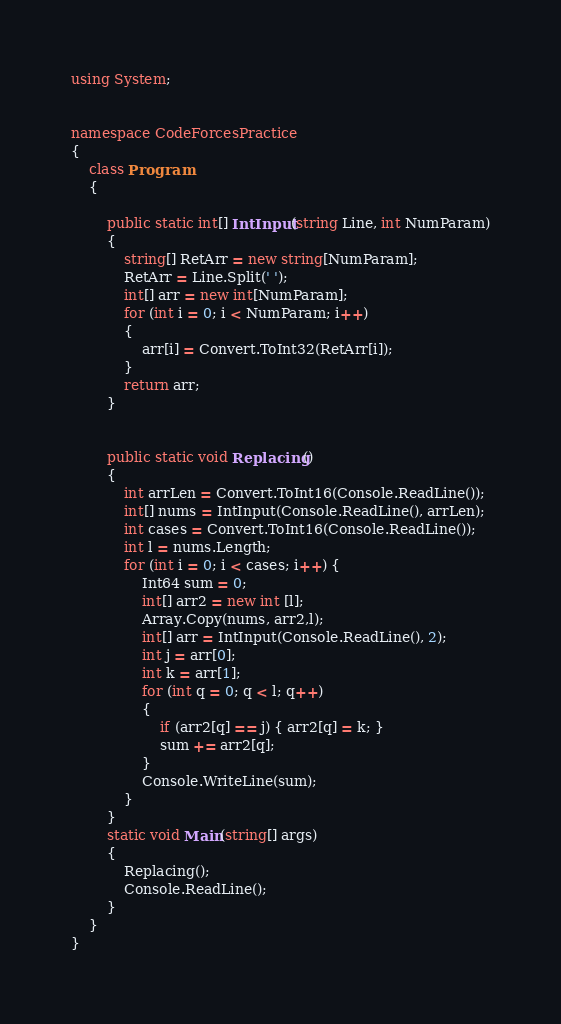Convert code to text. <code><loc_0><loc_0><loc_500><loc_500><_C#_>using System;


namespace CodeForcesPractice
{
    class Program
    {
        
        public static int[] IntInput(string Line, int NumParam)
        {
            string[] RetArr = new string[NumParam];
            RetArr = Line.Split(' ');
            int[] arr = new int[NumParam];
            for (int i = 0; i < NumParam; i++)
            {
                arr[i] = Convert.ToInt32(RetArr[i]);
            }
            return arr;
        }
        

        public static void Replacing()
        {
            int arrLen = Convert.ToInt16(Console.ReadLine());
            int[] nums = IntInput(Console.ReadLine(), arrLen);
            int cases = Convert.ToInt16(Console.ReadLine());
            int l = nums.Length;
            for (int i = 0; i < cases; i++) {
                Int64 sum = 0;
                int[] arr2 = new int [l];
                Array.Copy(nums, arr2,l);
                int[] arr = IntInput(Console.ReadLine(), 2);
                int j = arr[0];
                int k = arr[1];
                for (int q = 0; q < l; q++)
                {
                    if (arr2[q] == j) { arr2[q] = k; }
                    sum += arr2[q];
                }
                Console.WriteLine(sum);
            }
        }
        static void Main(string[] args)
        {
            Replacing();
            Console.ReadLine();
        }
    }
}
</code> 